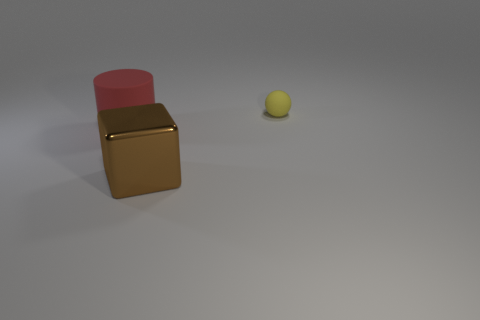There is a object that is made of the same material as the ball; what is its size?
Keep it short and to the point. Large. How many blocks are large red objects or brown objects?
Offer a terse response. 1. Is the number of big metallic objects greater than the number of tiny cyan matte things?
Make the answer very short. Yes. How many red objects have the same size as the brown object?
Your answer should be very brief. 1. How many things are either matte objects in front of the rubber ball or brown shiny balls?
Provide a succinct answer. 1. Is the number of blocks less than the number of small cyan cylinders?
Your response must be concise. No. What shape is the big object that is made of the same material as the sphere?
Your response must be concise. Cylinder. Are there any large brown metallic cubes in front of the big brown shiny thing?
Your answer should be very brief. No. Are there fewer red cylinders that are in front of the brown block than tiny cyan rubber things?
Offer a very short reply. No. What is the brown block made of?
Provide a short and direct response. Metal. 